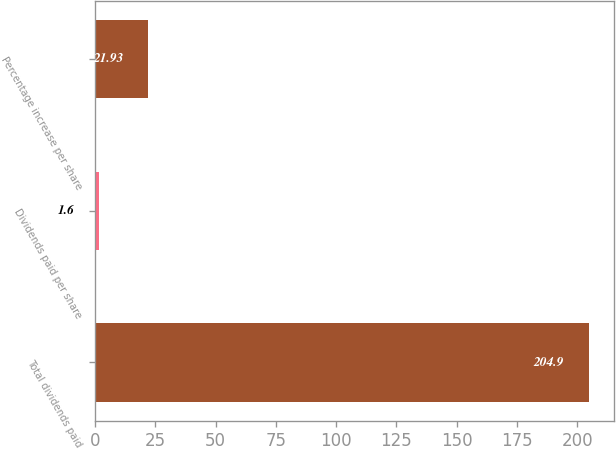<chart> <loc_0><loc_0><loc_500><loc_500><bar_chart><fcel>Total dividends paid<fcel>Dividends paid per share<fcel>Percentage increase per share<nl><fcel>204.9<fcel>1.6<fcel>21.93<nl></chart> 